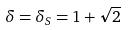Convert formula to latex. <formula><loc_0><loc_0><loc_500><loc_500>\delta = \delta _ { S } = 1 + \sqrt { 2 }</formula> 